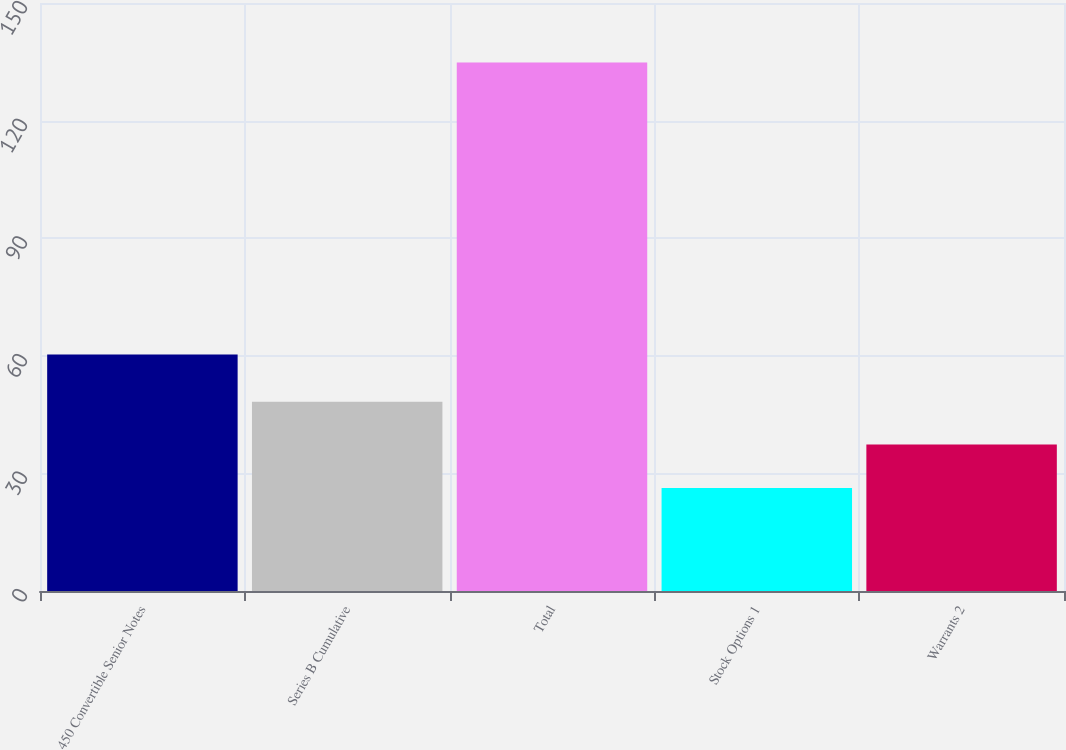Convert chart to OTSL. <chart><loc_0><loc_0><loc_500><loc_500><bar_chart><fcel>450 Convertible Senior Notes<fcel>Series B Cumulative<fcel>Total<fcel>Stock Options 1<fcel>Warrants 2<nl><fcel>60.3<fcel>48.25<fcel>134.8<fcel>26.3<fcel>37.4<nl></chart> 